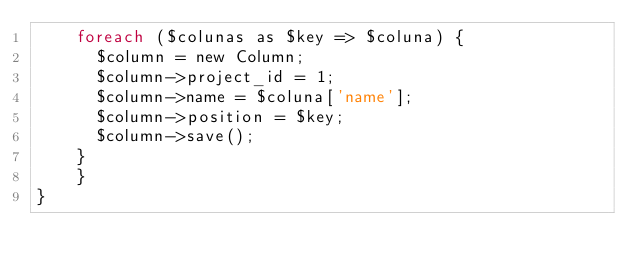Convert code to text. <code><loc_0><loc_0><loc_500><loc_500><_PHP_>		foreach ($colunas as $key => $coluna) {
			$column = new Column;
			$column->project_id = 1;
			$column->name = $coluna['name'];
			$column->position = $key;
			$column->save();
		}
    }
}
</code> 